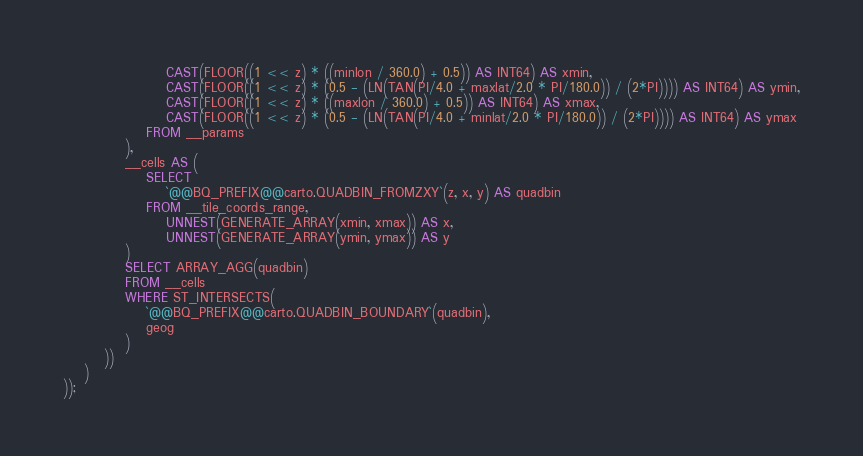<code> <loc_0><loc_0><loc_500><loc_500><_SQL_>                    CAST(FLOOR((1 << z) * ((minlon / 360.0) + 0.5)) AS INT64) AS xmin,
                    CAST(FLOOR((1 << z) * (0.5 - (LN(TAN(PI/4.0 + maxlat/2.0 * PI/180.0)) / (2*PI)))) AS INT64) AS ymin,
                    CAST(FLOOR((1 << z) * ((maxlon / 360.0) + 0.5)) AS INT64) AS xmax,
                    CAST(FLOOR((1 << z) * (0.5 - (LN(TAN(PI/4.0 + minlat/2.0 * PI/180.0)) / (2*PI)))) AS INT64) AS ymax
                FROM __params
            ),
            __cells AS (
                SELECT
                    `@@BQ_PREFIX@@carto.QUADBIN_FROMZXY`(z, x, y) AS quadbin
                FROM __tile_coords_range,
                    UNNEST(GENERATE_ARRAY(xmin, xmax)) AS x,
                    UNNEST(GENERATE_ARRAY(ymin, ymax)) AS y
            )
            SELECT ARRAY_AGG(quadbin)
            FROM __cells
            WHERE ST_INTERSECTS(
                `@@BQ_PREFIX@@carto.QUADBIN_BOUNDARY`(quadbin),
                geog
            )
        ))
    )
));</code> 